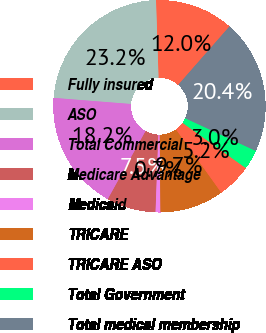Convert chart. <chart><loc_0><loc_0><loc_500><loc_500><pie_chart><fcel>Fully insured<fcel>ASO<fcel>Total Commercial<fcel>Medicare Advantage<fcel>Medicaid<fcel>TRICARE<fcel>TRICARE ASO<fcel>Total Government<fcel>Total medical membership<nl><fcel>11.98%<fcel>23.22%<fcel>18.19%<fcel>7.48%<fcel>0.74%<fcel>9.73%<fcel>5.23%<fcel>2.98%<fcel>20.44%<nl></chart> 